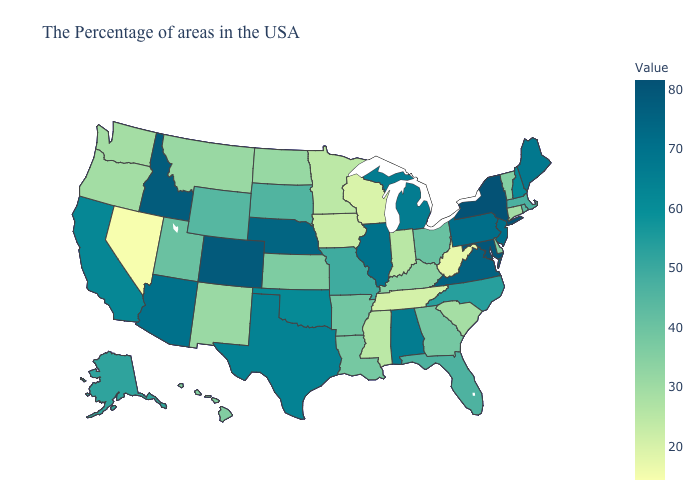Which states have the lowest value in the USA?
Short answer required. Nevada. Which states have the lowest value in the USA?
Answer briefly. Nevada. Which states have the lowest value in the West?
Be succinct. Nevada. Which states have the lowest value in the USA?
Answer briefly. Nevada. Does West Virginia have the highest value in the USA?
Keep it brief. No. Which states have the lowest value in the South?
Be succinct. West Virginia. Does Utah have the lowest value in the USA?
Short answer required. No. 